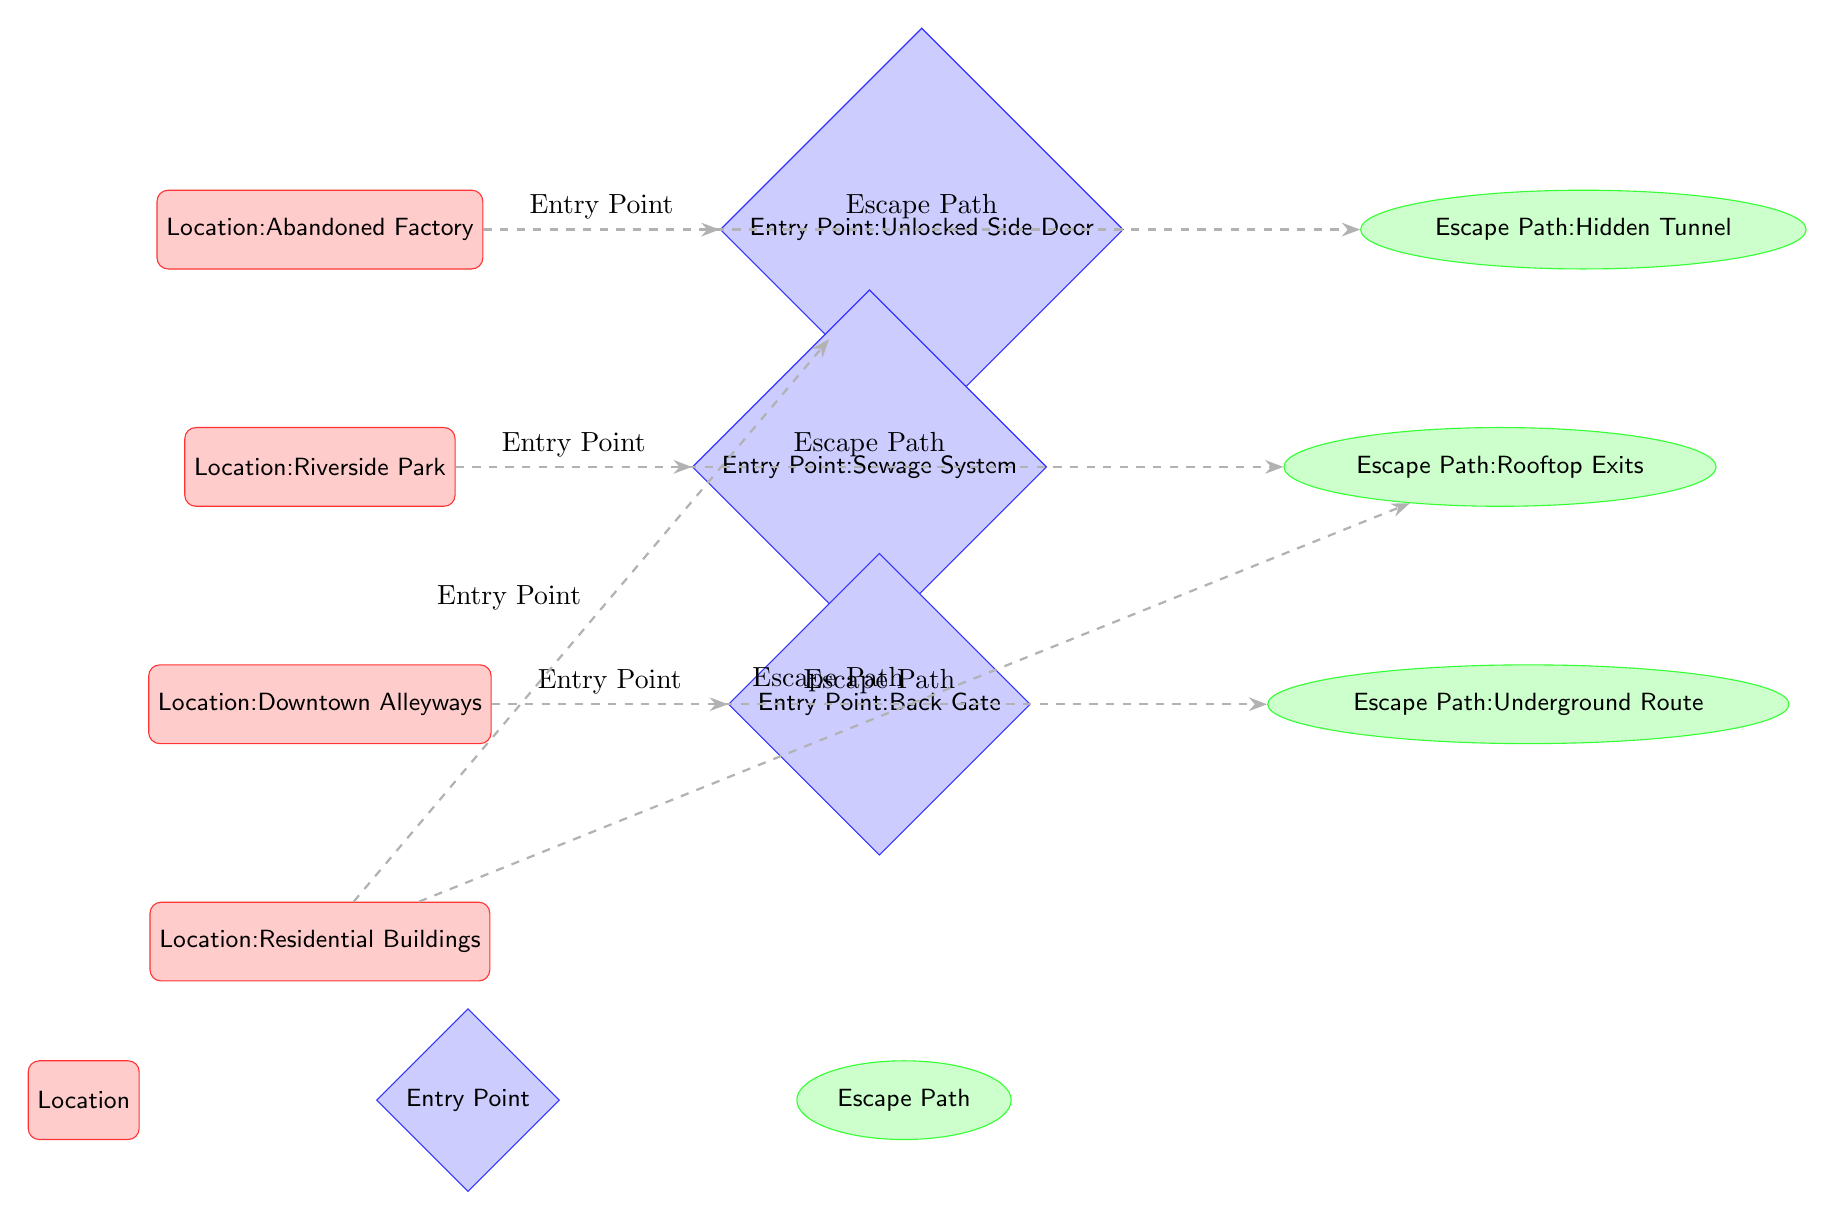What is the first location listed in the diagram? The diagram shows four locations, and the first one is noted at the top. By following the vertical order of the boxes, the first location is "Abandoned Factory."
Answer: Abandoned Factory How many entry points are depicted in the diagram? The diagram includes three entry points, as shown in the diamond-shaped nodes including the entries near the "Abandoned Factory," "Riverside Park," and "Downtown Alleyways."
Answer: 3 What escape path is associated with the "Riverside Park"? By examining the connection between the "Riverside Park" location and its corresponding escape path, the escape path linked to it is the "Rooftop Exits."
Answer: Rooftop Exits Which entry point is used by the "Residential Buildings"? To find the entry point used for "Residential Buildings," the routes lead from the location and the only entry point connected from this node is the "Unlocked Side Door."
Answer: Unlocked Side Door Identify the escape path related to "Downtown Alleyways" The escape path corresponding to "Downtown Alleyways" can be determined by reviewing the connections, leading us to identify the "Underground Route."
Answer: Underground Route Which location has an escape path that is also a rooftop exit? Examining the escape paths, the "Rooftop Exits" is clearly linked to "Riverside Park," making this the location associated with rooftop exits. The other locations do not list this escape path.
Answer: Riverside Park What is the relationship between "Downtown Alleyways" and its escape route? The relationship is direct, as there is a solid route drawn from "Downtown Alleyways" to the escape path called "Underground Route," indicating how an individual might exit from that location back to safety.
Answer: Escape Route How many total nodes represent locations in the diagram? Counting the rectangles representing locations reveals there are four nodes in total, which are specifically designated as locations related to illegal activities.
Answer: 4 What color represents the escape paths in the diagram? The escape paths are visually indicated in green, both in the filling color of the ellipses and in the connected dashed routes.
Answer: Green 